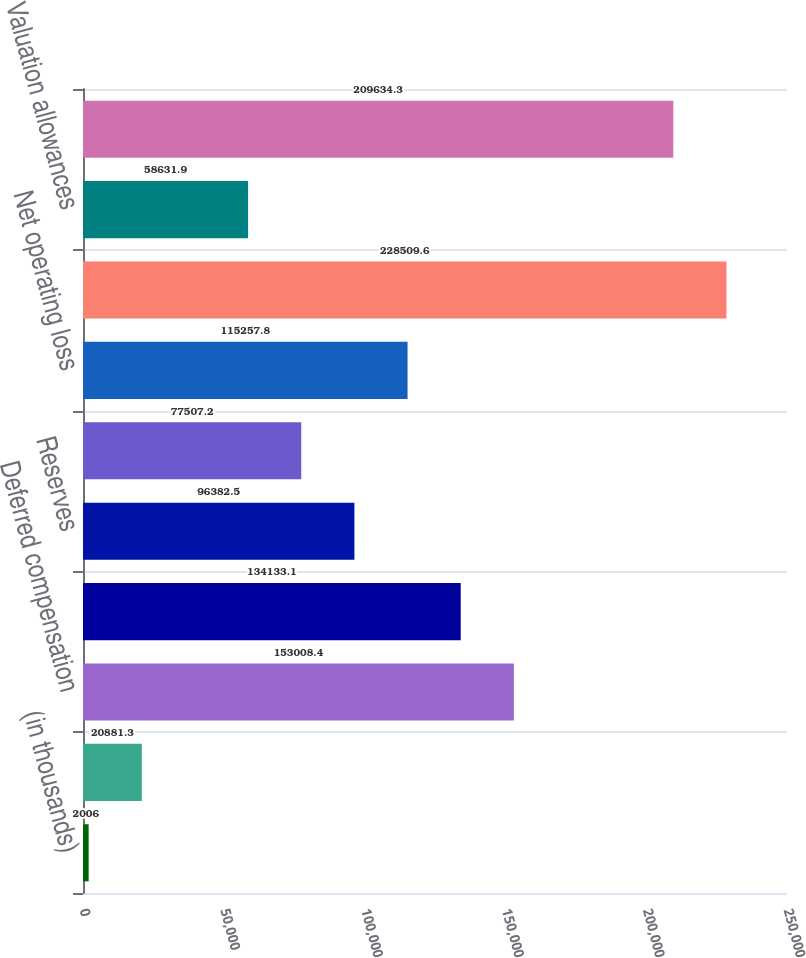Convert chart. <chart><loc_0><loc_0><loc_500><loc_500><bar_chart><fcel>(in thousands)<fcel>Accounts receivable<fcel>Deferred compensation<fcel>Pension<fcel>Reserves<fcel>Tax credit carryforwards/other<fcel>Net operating loss<fcel>Total gross deferred tax<fcel>Valuation allowances<fcel>Total deferred tax assets<nl><fcel>2006<fcel>20881.3<fcel>153008<fcel>134133<fcel>96382.5<fcel>77507.2<fcel>115258<fcel>228510<fcel>58631.9<fcel>209634<nl></chart> 